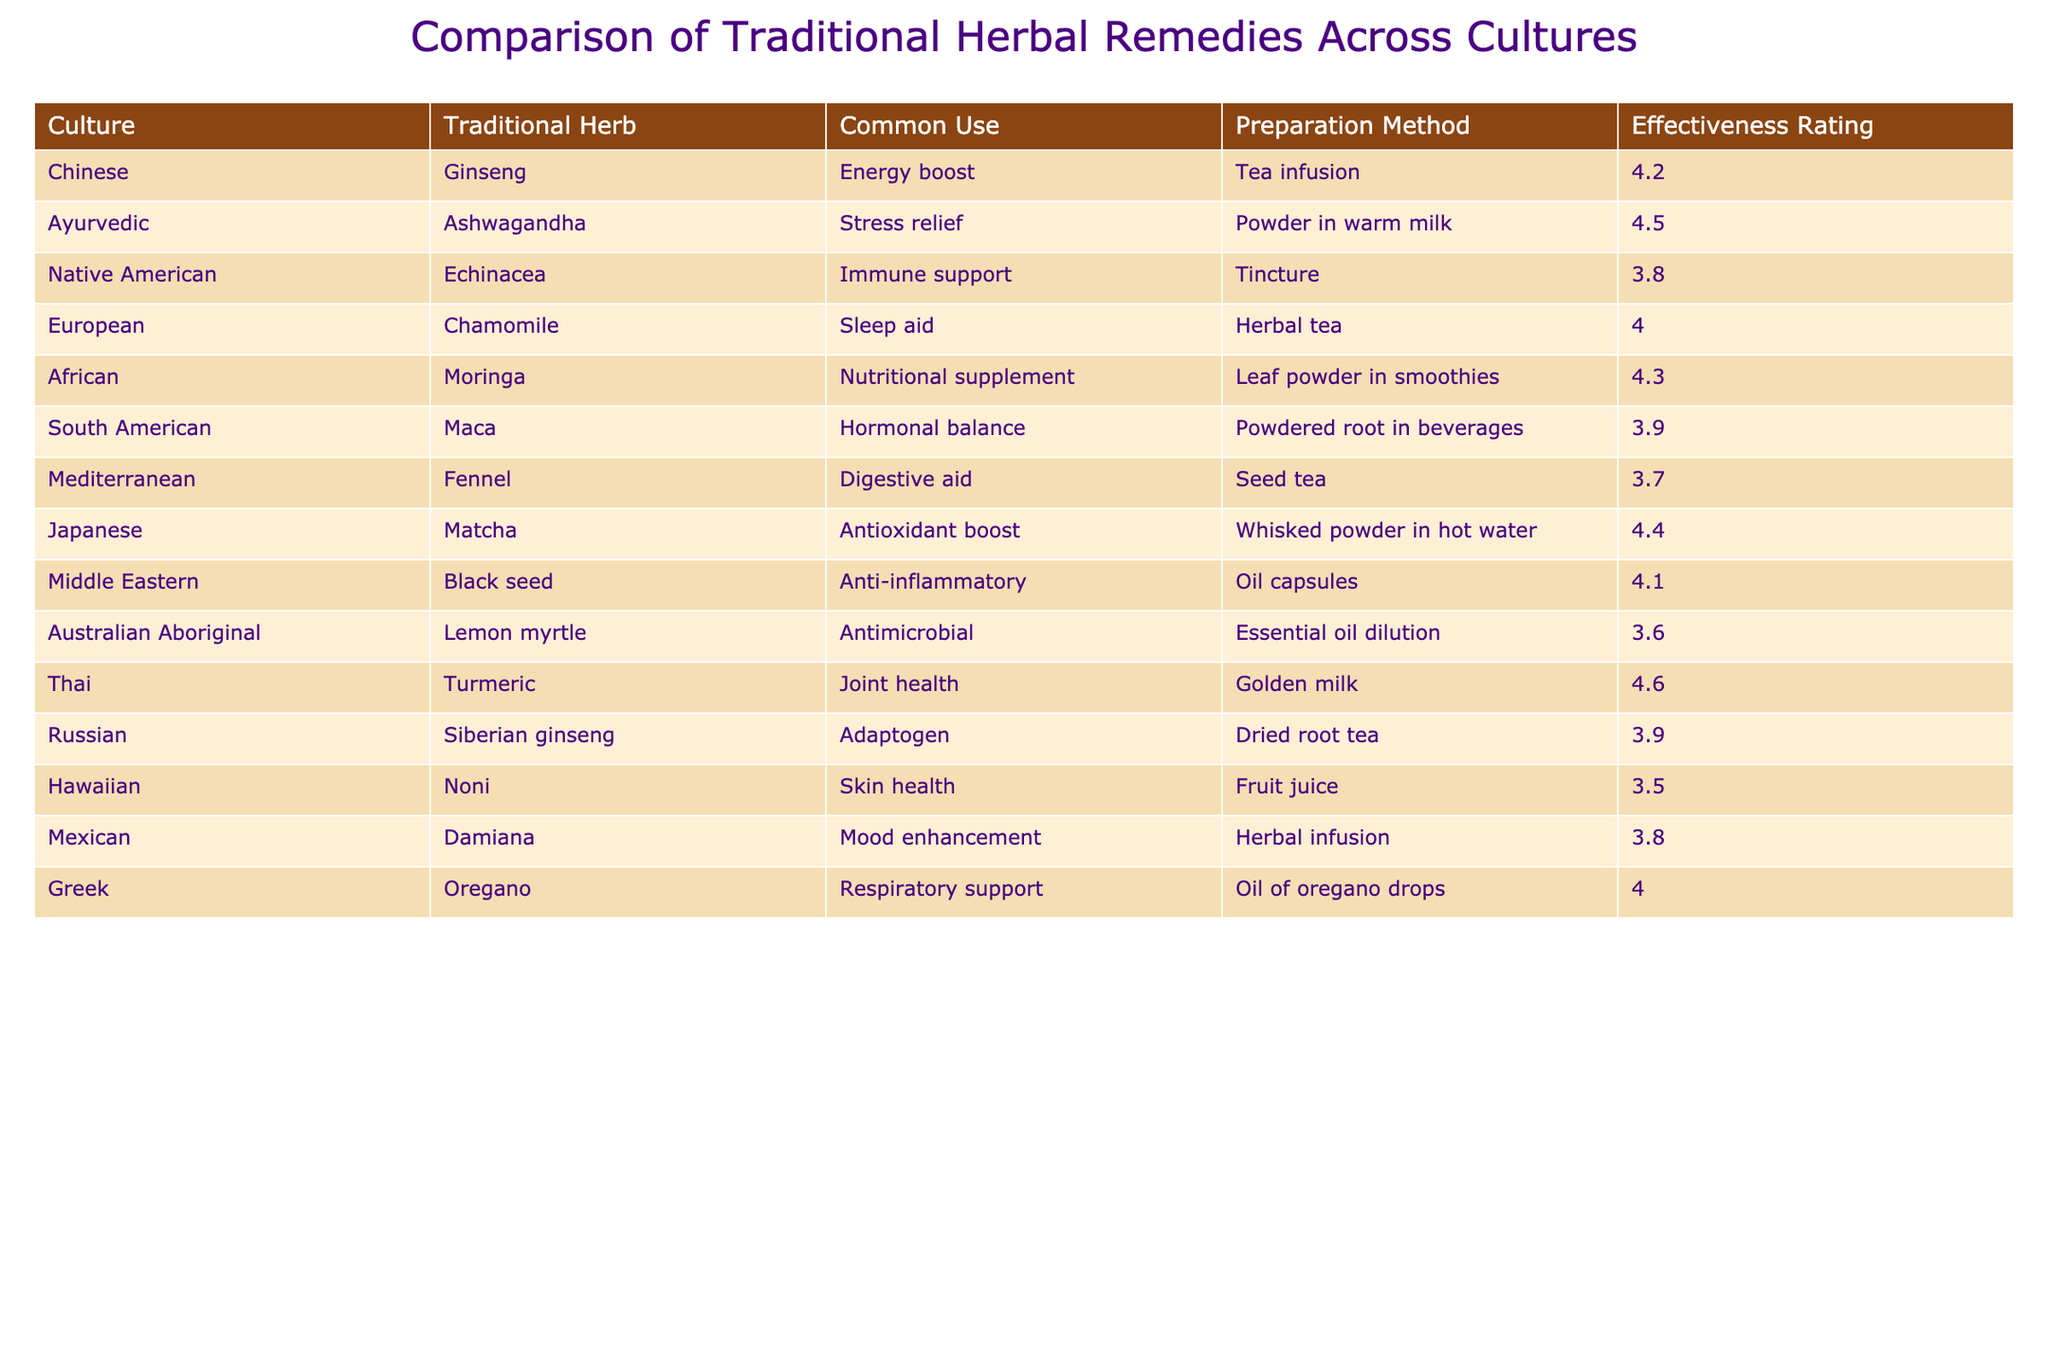What is the traditional herb used in Ayurvedic medicine? The table lists the traditional herb associated with Ayurvedic medicine as Ashwagandha.
Answer: Ashwagandha Which traditional herb has the highest effectiveness rating? Upon reviewing the effectiveness ratings, I find that Turmeric, used in Thai culture, has the highest rating of 4.6.
Answer: Turmeric Is Echinacea commonly used for stress relief? According to the table, Echinacea is primarily used for immune support, not stress relief.
Answer: No What is the common use of Ginseng in Chinese tradition? The table indicates that Ginseng is commonly used for an energy boost in Chinese tradition.
Answer: Energy boost Calculate the average effectiveness rating of all listed herbs. The effectiveness ratings are: 4.2, 4.5, 3.8, 4.0, 4.3, 3.9, 3.7, 4.4, 4.1, 3.6, 4.6, 3.9, 3.5, 3.8, 4.0. Adding these together gives 60.6, and dividing by 15 (the number of herbs) results in an average effectiveness rating of 4.04.
Answer: 4.04 Which preparation method is used for Moringa? The table specifies that Moringa is prepared as leaf powder in smoothies.
Answer: Leaf powder in smoothies Does the Middle Eastern culture use a herb for skin health? The table shows that the Middle Eastern region does not have a herb listed for skin health; instead, Noni is associated with Hawaiian culture for this purpose.
Answer: No What is the effectiveness rating of Chamomile compared to that of Black seed? Chamomile has an effectiveness rating of 4.0, while Black seed has a rating of 4.1. Comparing these, Black seed is rated slightly higher.
Answer: Black seed is rated higher List two traditional herbs that are used for immune support. The table lists Echinacea and Ginseng for immune support, with Echinacea specifically noted for this use.
Answer: Echinacea, Ginseng Which culture uses Chamomile historically? According to the table, Chamomile is historically used in European culture.
Answer: European If we consider the effectiveness ratings of herbs from the Mediterranean and African cultures, which is more effective? The effectiveness rating for Fennel from Mediterranean culture is 3.7, and for Moringa from African culture, it is 4.3. Since 4.3 (Moringa) is greater than 3.7 (Fennel), African is more effective.
Answer: African is more effective 